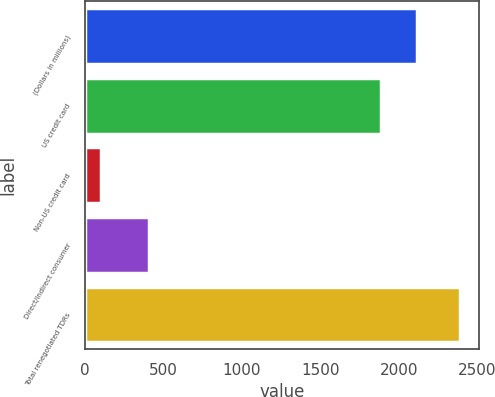<chart> <loc_0><loc_0><loc_500><loc_500><bar_chart><fcel>(Dollars in millions)<fcel>US credit card<fcel>Non-US credit card<fcel>Direct/Indirect consumer<fcel>Total renegotiated TDRs<nl><fcel>2116.2<fcel>1887<fcel>99<fcel>405<fcel>2391<nl></chart> 